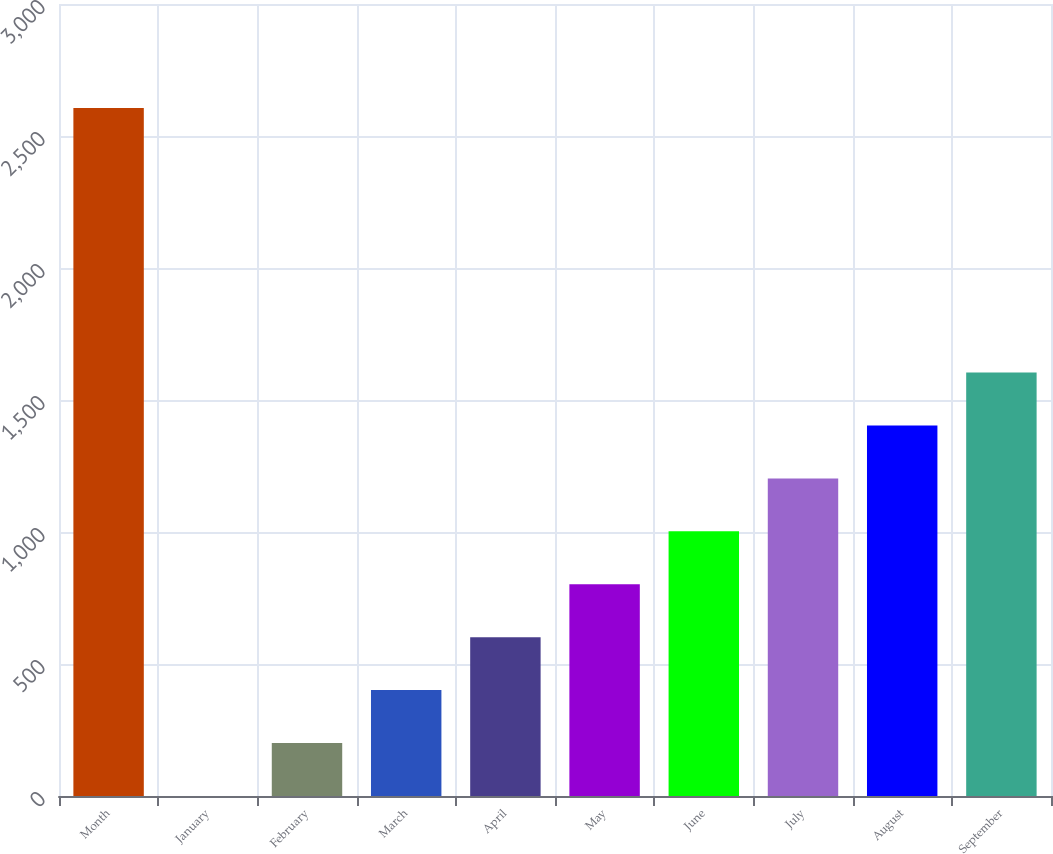Convert chart to OTSL. <chart><loc_0><loc_0><loc_500><loc_500><bar_chart><fcel>Month<fcel>January<fcel>February<fcel>March<fcel>April<fcel>May<fcel>June<fcel>July<fcel>August<fcel>September<nl><fcel>2606.48<fcel>0.11<fcel>200.6<fcel>401.09<fcel>601.58<fcel>802.07<fcel>1002.56<fcel>1203.05<fcel>1403.54<fcel>1604.03<nl></chart> 